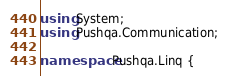<code> <loc_0><loc_0><loc_500><loc_500><_C#_>using System;
using Pushqa.Communication;

namespace Pushqa.Linq {</code> 